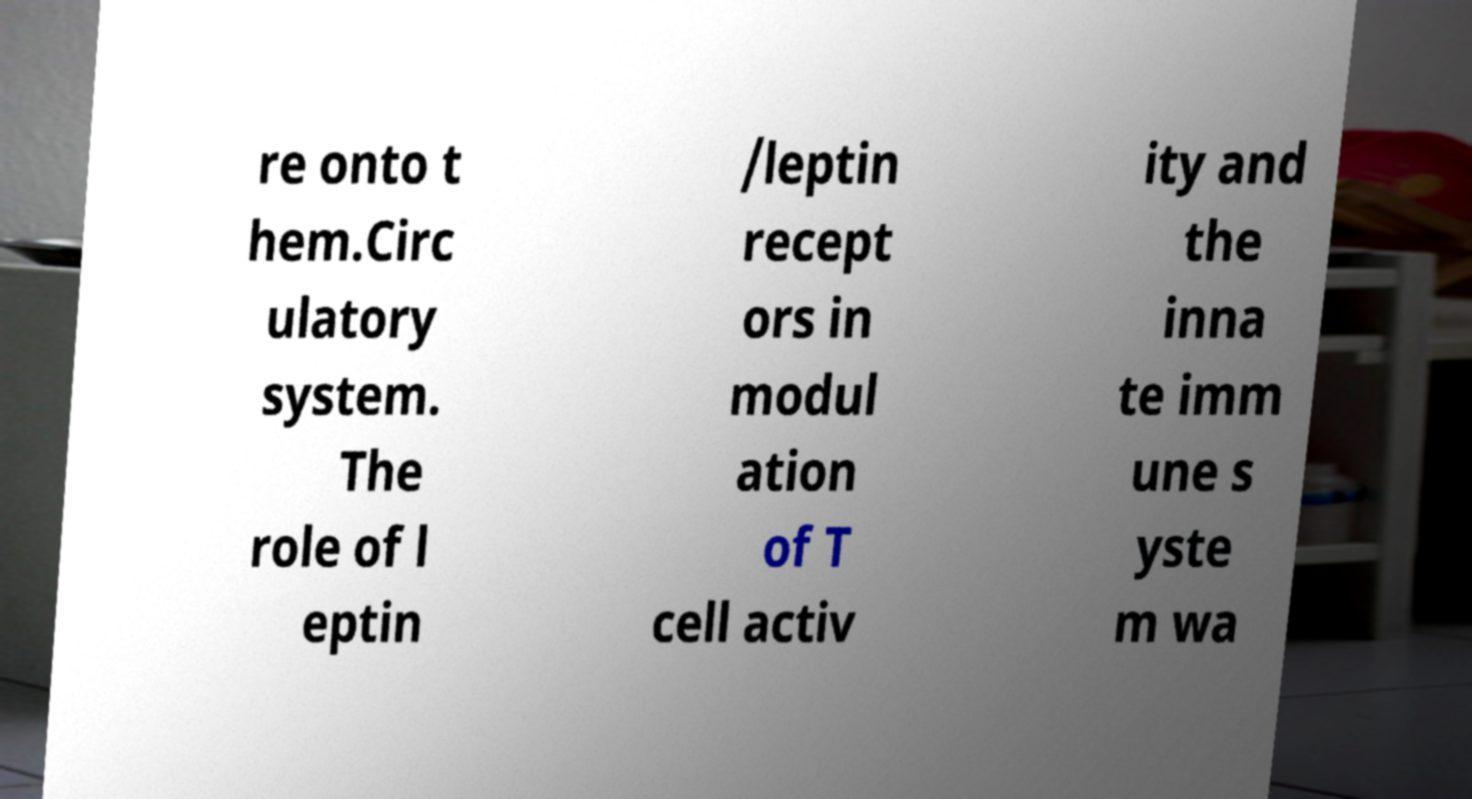Could you assist in decoding the text presented in this image and type it out clearly? re onto t hem.Circ ulatory system. The role of l eptin /leptin recept ors in modul ation of T cell activ ity and the inna te imm une s yste m wa 